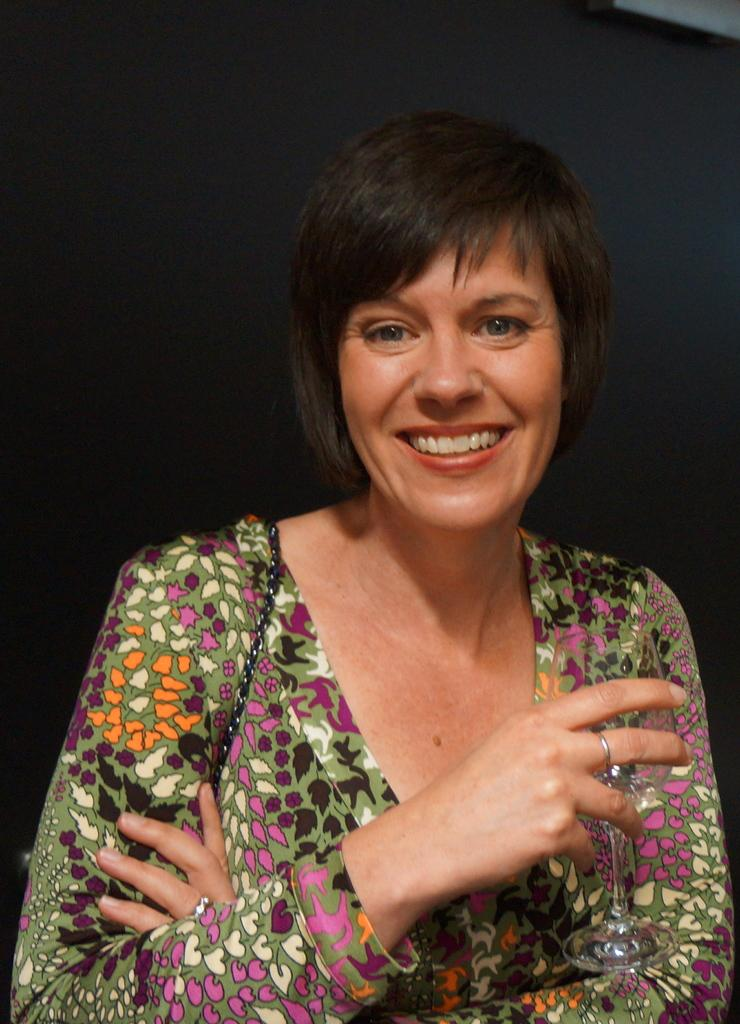What is the main subject of the image? The main subject of the image is a woman. What is the woman doing in the image? The woman is smiling in the image. What object is the woman holding? The woman is holding a glass. What can be seen in the background of the image? There is a wall in the background of the image. Can you see a ring on the woman's finger in the image? There is no ring visible on the woman's finger in the image. Where is the seashore located in the image? There is no seashore present in the image. 